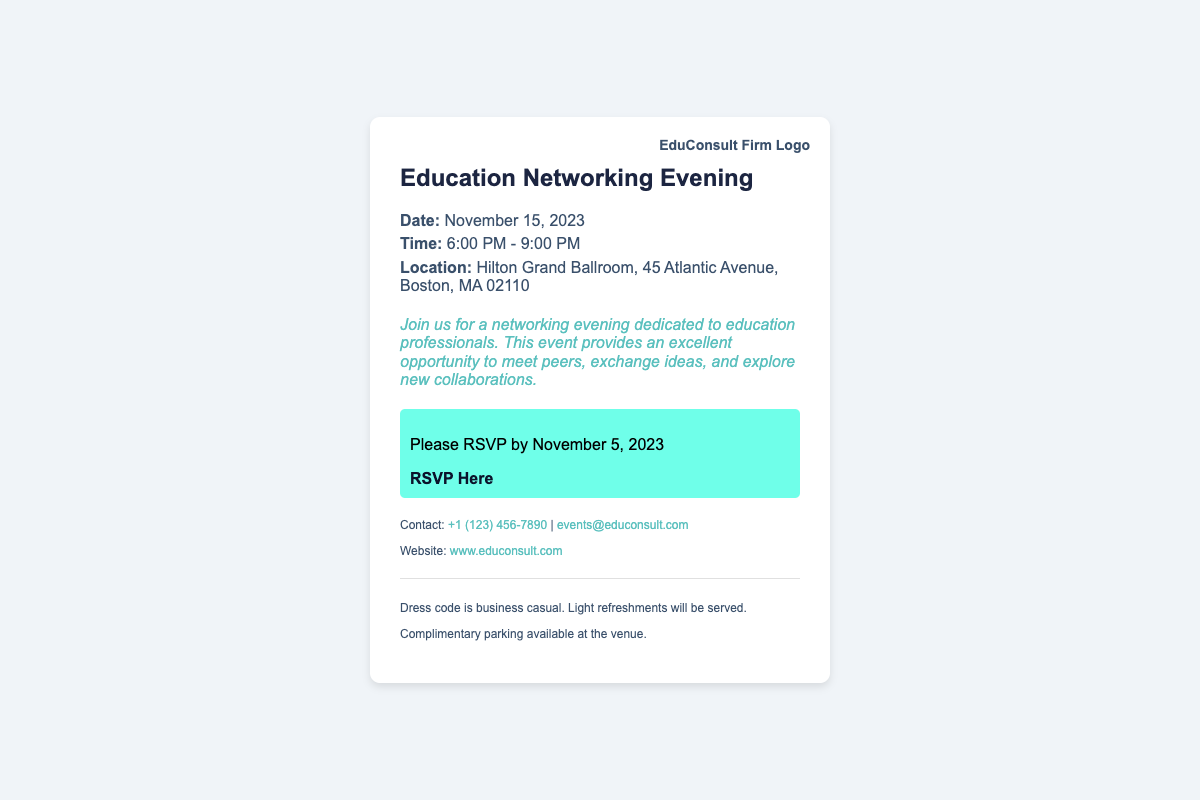What is the date of the event? The date is specified in the document under the details section.
Answer: November 15, 2023 What time does the event start? The starting time is included in the details section of the document.
Answer: 6:00 PM What is the location of the networking event? The location is provided in the details section that specifies the venue for the event.
Answer: Hilton Grand Ballroom, 45 Atlantic Avenue, Boston, MA 02110 By when should I RSVP? The RSVP deadline is clearly mentioned in the RSVP section of the document.
Answer: November 5, 2023 What is the dress code for the event? The dress code information is included in the additional section of the document.
Answer: Business casual What type of refreshments will be served? Light refreshments information is found in the additional section of the document.
Answer: Light refreshments How can I contact the event organizers? Contact information is listed in the contact section, allowing for direct communication.
Answer: +1 (123) 456-7890 Is parking available at the venue? Parking availability is mentioned in the additional section of the document.
Answer: Complimentary parking available 